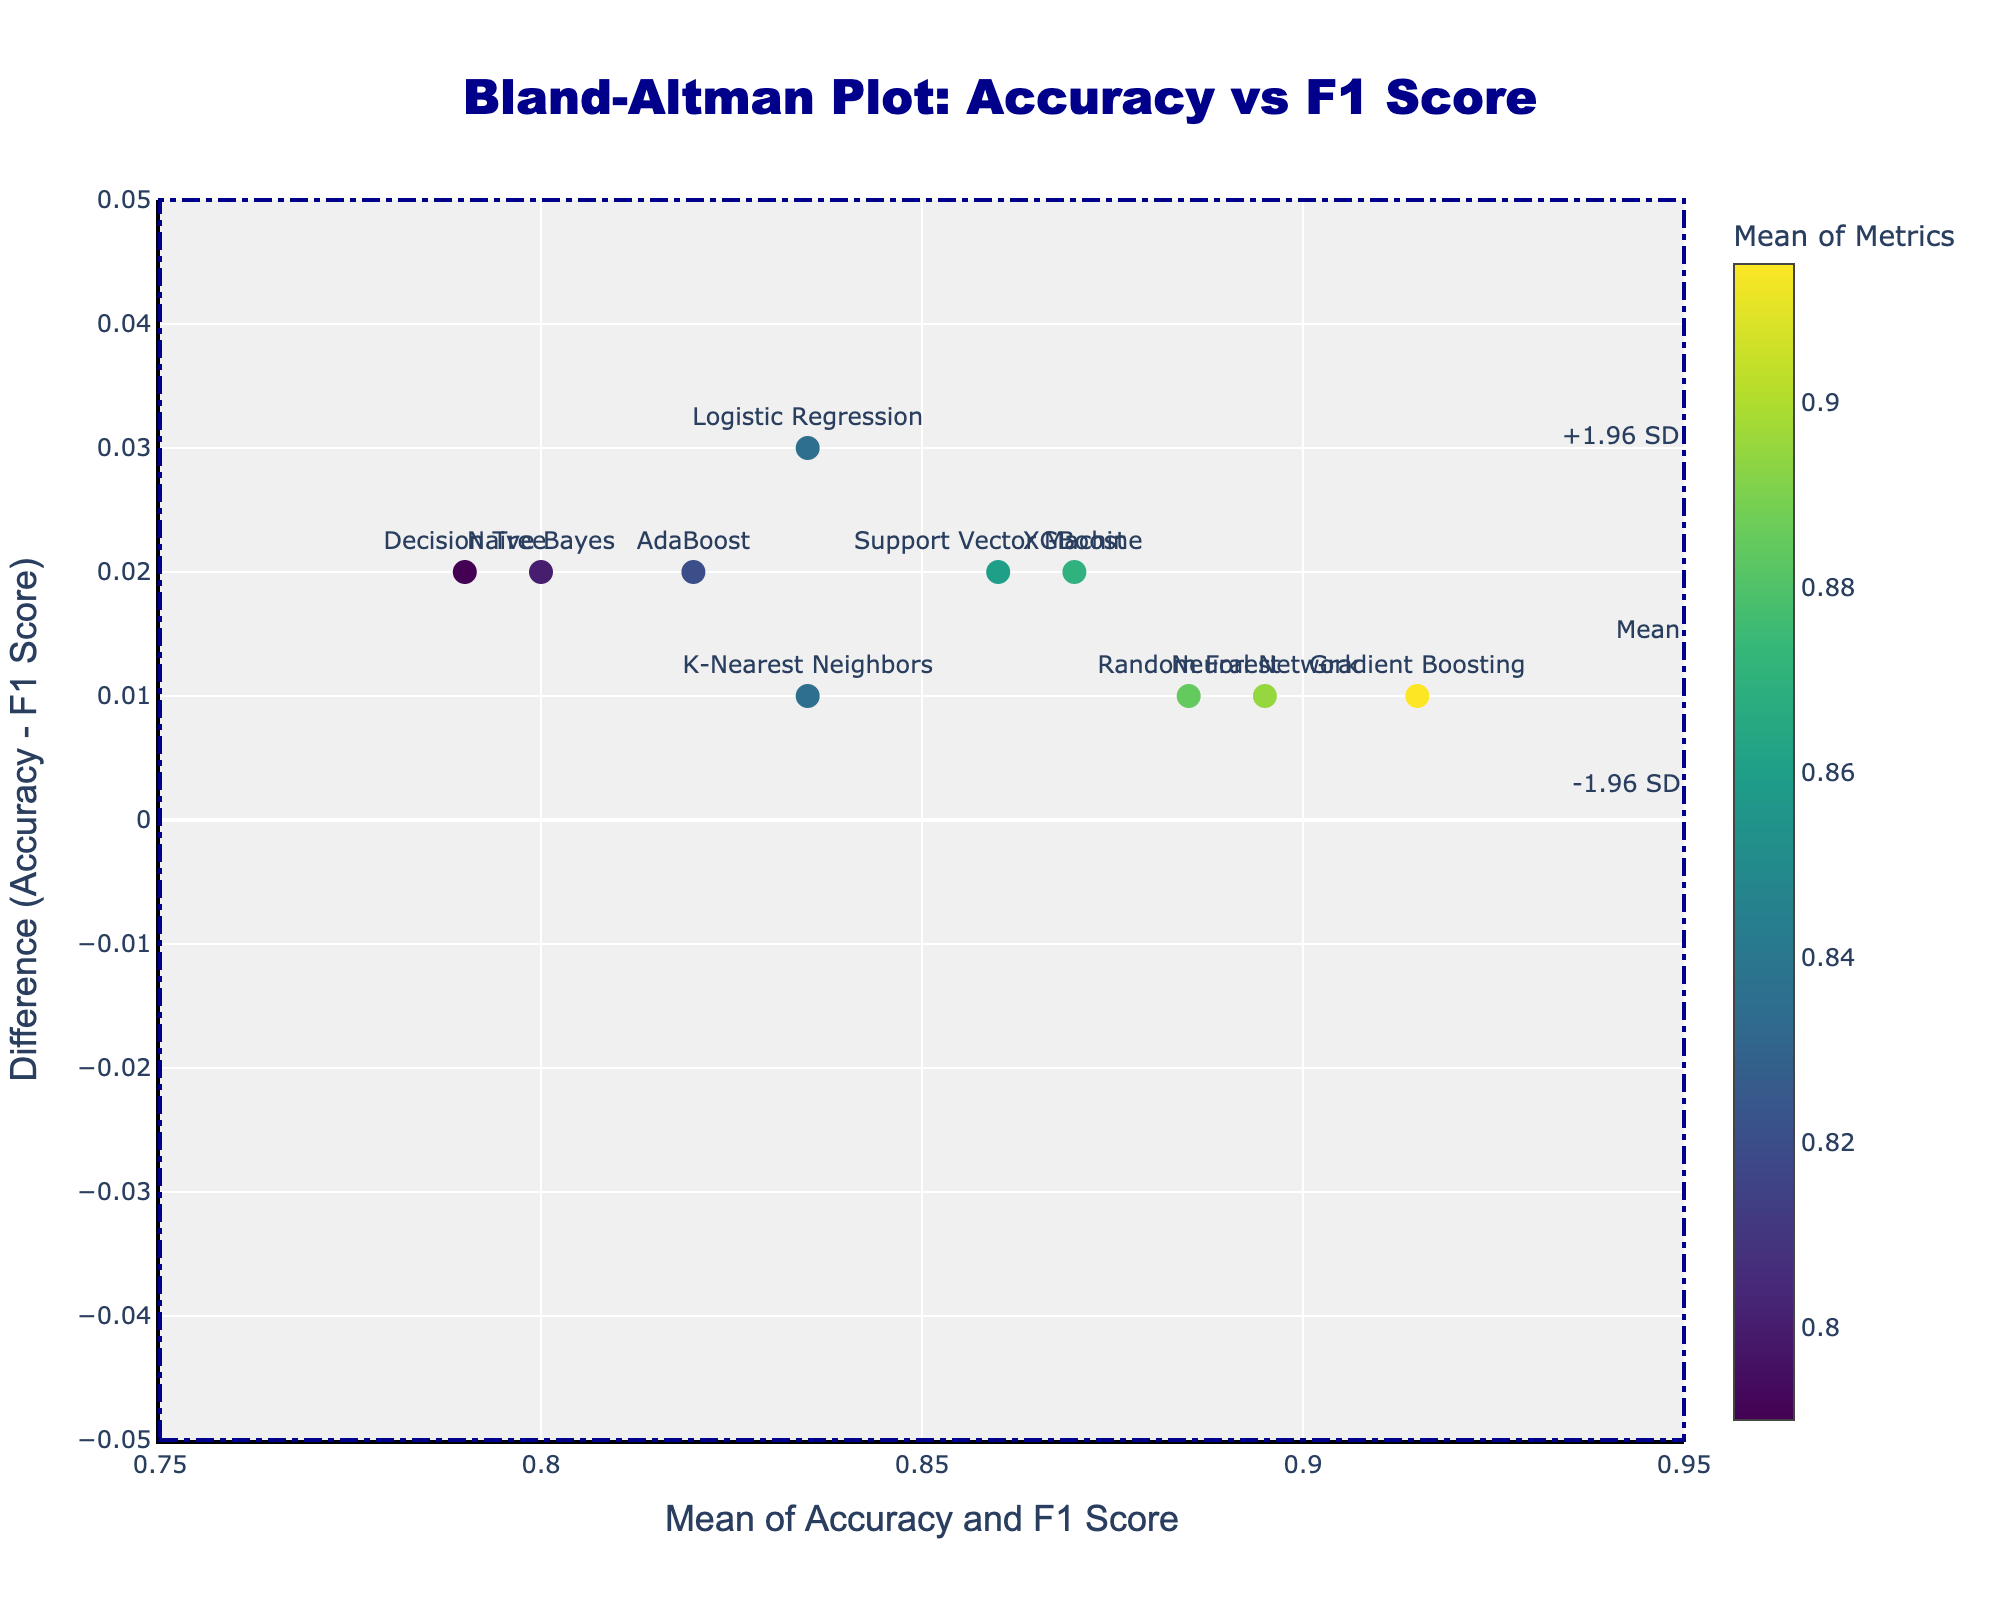What is the title of the plot? The plot's title is at the top center, and it reads "Bland-Altman Plot: Accuracy vs F1 Score."
Answer: Bland-Altman Plot: Accuracy vs F1 Score How many data points are shown in the plot? Each data point corresponds to a model, marked by colored dots with labels. There are 10 models, so there are 10 data points.
Answer: 10 Which model has the highest mean of Accuracy and F1 Score? The mean value is calculated as (Accuracy + F1 Score) / 2. Gradient Boosting, with scores 0.92 and 0.91, results in a mean of (0.92+0.91)/2 = 0.915, which is the highest.
Answer: Gradient Boosting What is the range of the y-axis in the plot? The y-axis range is specified from -0.05 to 0.05 as indicated by the axis settings at the bottom and top of the vertical axis.
Answer: -0.05 to 0.05 What are the dashed and dotted lines representing in the plot? The dashed line represents the mean difference, while the dotted lines represent the limits of agreement, specifically ±1.96 standard deviations from the mean difference.
Answer: Mean difference and limits of agreement What is the difference between Accuracy and F1 Score for the XGBoost model? Locate the "XGBoost" label on the plot. The difference (Accuracy - F1 Score) for XGBoost is 0.88 - 0.86 = 0.02.
Answer: 0.02 Which model shows the largest discrepancy between Accuracy and F1 Score? Identify the model with the largest vertical distance from the y=0 line. Gradient Boosting shows the largest discrepancy, with a difference of 0.92 - 0.91 = 0.01, as it lies furthest from the y=0 axis.
Answer: Gradient Boosting Is there any model falling above the +1.96 SD line or below the -1.96 SD line? Review the dotted lines representing ±1.96 SD. No data points or model labels lie above or below these lines.
Answer: No What is the mean value of Accuracy and F1 Score for the Neural Network model? For Neural Network, Accuracy is 0.90, and F1 Score is 0.89. The mean is calculated as (0.90 + 0.89) / 2 = 0.895.
Answer: 0.895 What color represents the mean metric value of 0.84 on the plot? The color scale on the right of the plot indicates shades in the 'Viridis' scale. The mean value of 0.84 corresponds to a color near the middle of the color range, around green/yellow.
Answer: Green/yellow 